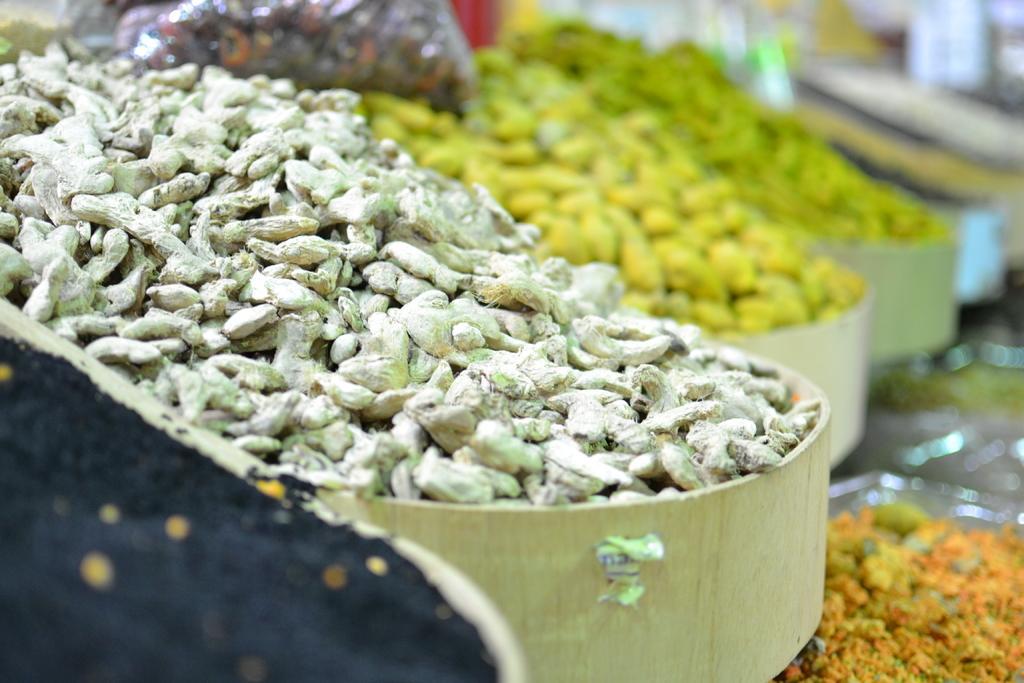Can you describe this image briefly? In this image, we can see spices on bowls. In the background, image is blurred. 